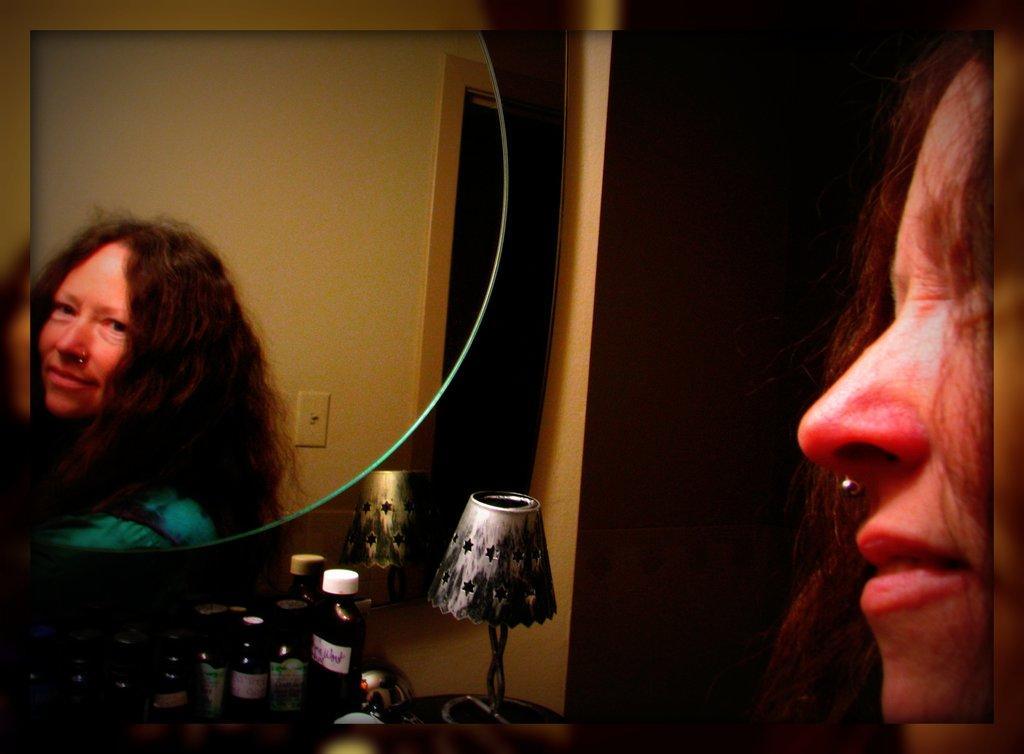In one or two sentences, can you explain what this image depicts? This is an edited image, where there is a woman looking into the mirror ,which is attached to the wall, there are bottles and a lamp on the table, and in the background there is a wall. 